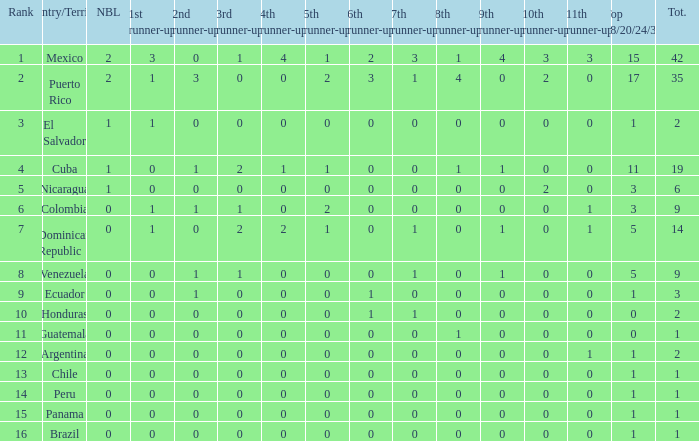What is the 9th runner-up with a top 18/20/24/30 greater than 17 and a 5th runner-up of 2? None. Could you parse the entire table as a dict? {'header': ['Rank', 'Country/Territory', 'NBL', '1st runner-up', '2nd runner-up', '3rd runner-up', '4th runner-up', '5th runner-up', '6th runner-up', '7th runner-up', '8th runner-up', '9th runner-up', '10th runner-up', '11th runner-up', 'Top 18/20/24/30', 'Tot.'], 'rows': [['1', 'Mexico', '2', '3', '0', '1', '4', '1', '2', '3', '1', '4', '3', '3', '15', '42'], ['2', 'Puerto Rico', '2', '1', '3', '0', '0', '2', '3', '1', '4', '0', '2', '0', '17', '35'], ['3', 'El Salvador', '1', '1', '0', '0', '0', '0', '0', '0', '0', '0', '0', '0', '1', '2'], ['4', 'Cuba', '1', '0', '1', '2', '1', '1', '0', '0', '1', '1', '0', '0', '11', '19'], ['5', 'Nicaragua', '1', '0', '0', '0', '0', '0', '0', '0', '0', '0', '2', '0', '3', '6'], ['6', 'Colombia', '0', '1', '1', '1', '0', '2', '0', '0', '0', '0', '0', '1', '3', '9'], ['7', 'Dominican Republic', '0', '1', '0', '2', '2', '1', '0', '1', '0', '1', '0', '1', '5', '14'], ['8', 'Venezuela', '0', '0', '1', '1', '0', '0', '0', '1', '0', '1', '0', '0', '5', '9'], ['9', 'Ecuador', '0', '0', '1', '0', '0', '0', '1', '0', '0', '0', '0', '0', '1', '3'], ['10', 'Honduras', '0', '0', '0', '0', '0', '0', '1', '1', '0', '0', '0', '0', '0', '2'], ['11', 'Guatemala', '0', '0', '0', '0', '0', '0', '0', '0', '1', '0', '0', '0', '0', '1'], ['12', 'Argentina', '0', '0', '0', '0', '0', '0', '0', '0', '0', '0', '0', '1', '1', '2'], ['13', 'Chile', '0', '0', '0', '0', '0', '0', '0', '0', '0', '0', '0', '0', '1', '1'], ['14', 'Peru', '0', '0', '0', '0', '0', '0', '0', '0', '0', '0', '0', '0', '1', '1'], ['15', 'Panama', '0', '0', '0', '0', '0', '0', '0', '0', '0', '0', '0', '0', '1', '1'], ['16', 'Brazil', '0', '0', '0', '0', '0', '0', '0', '0', '0', '0', '0', '0', '1', '1']]} 